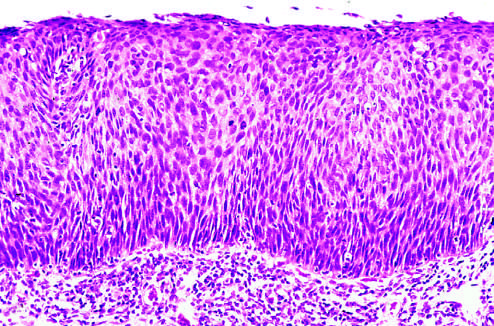what is there in the subepithelial stroma?
Answer the question using a single word or phrase. No tumor 